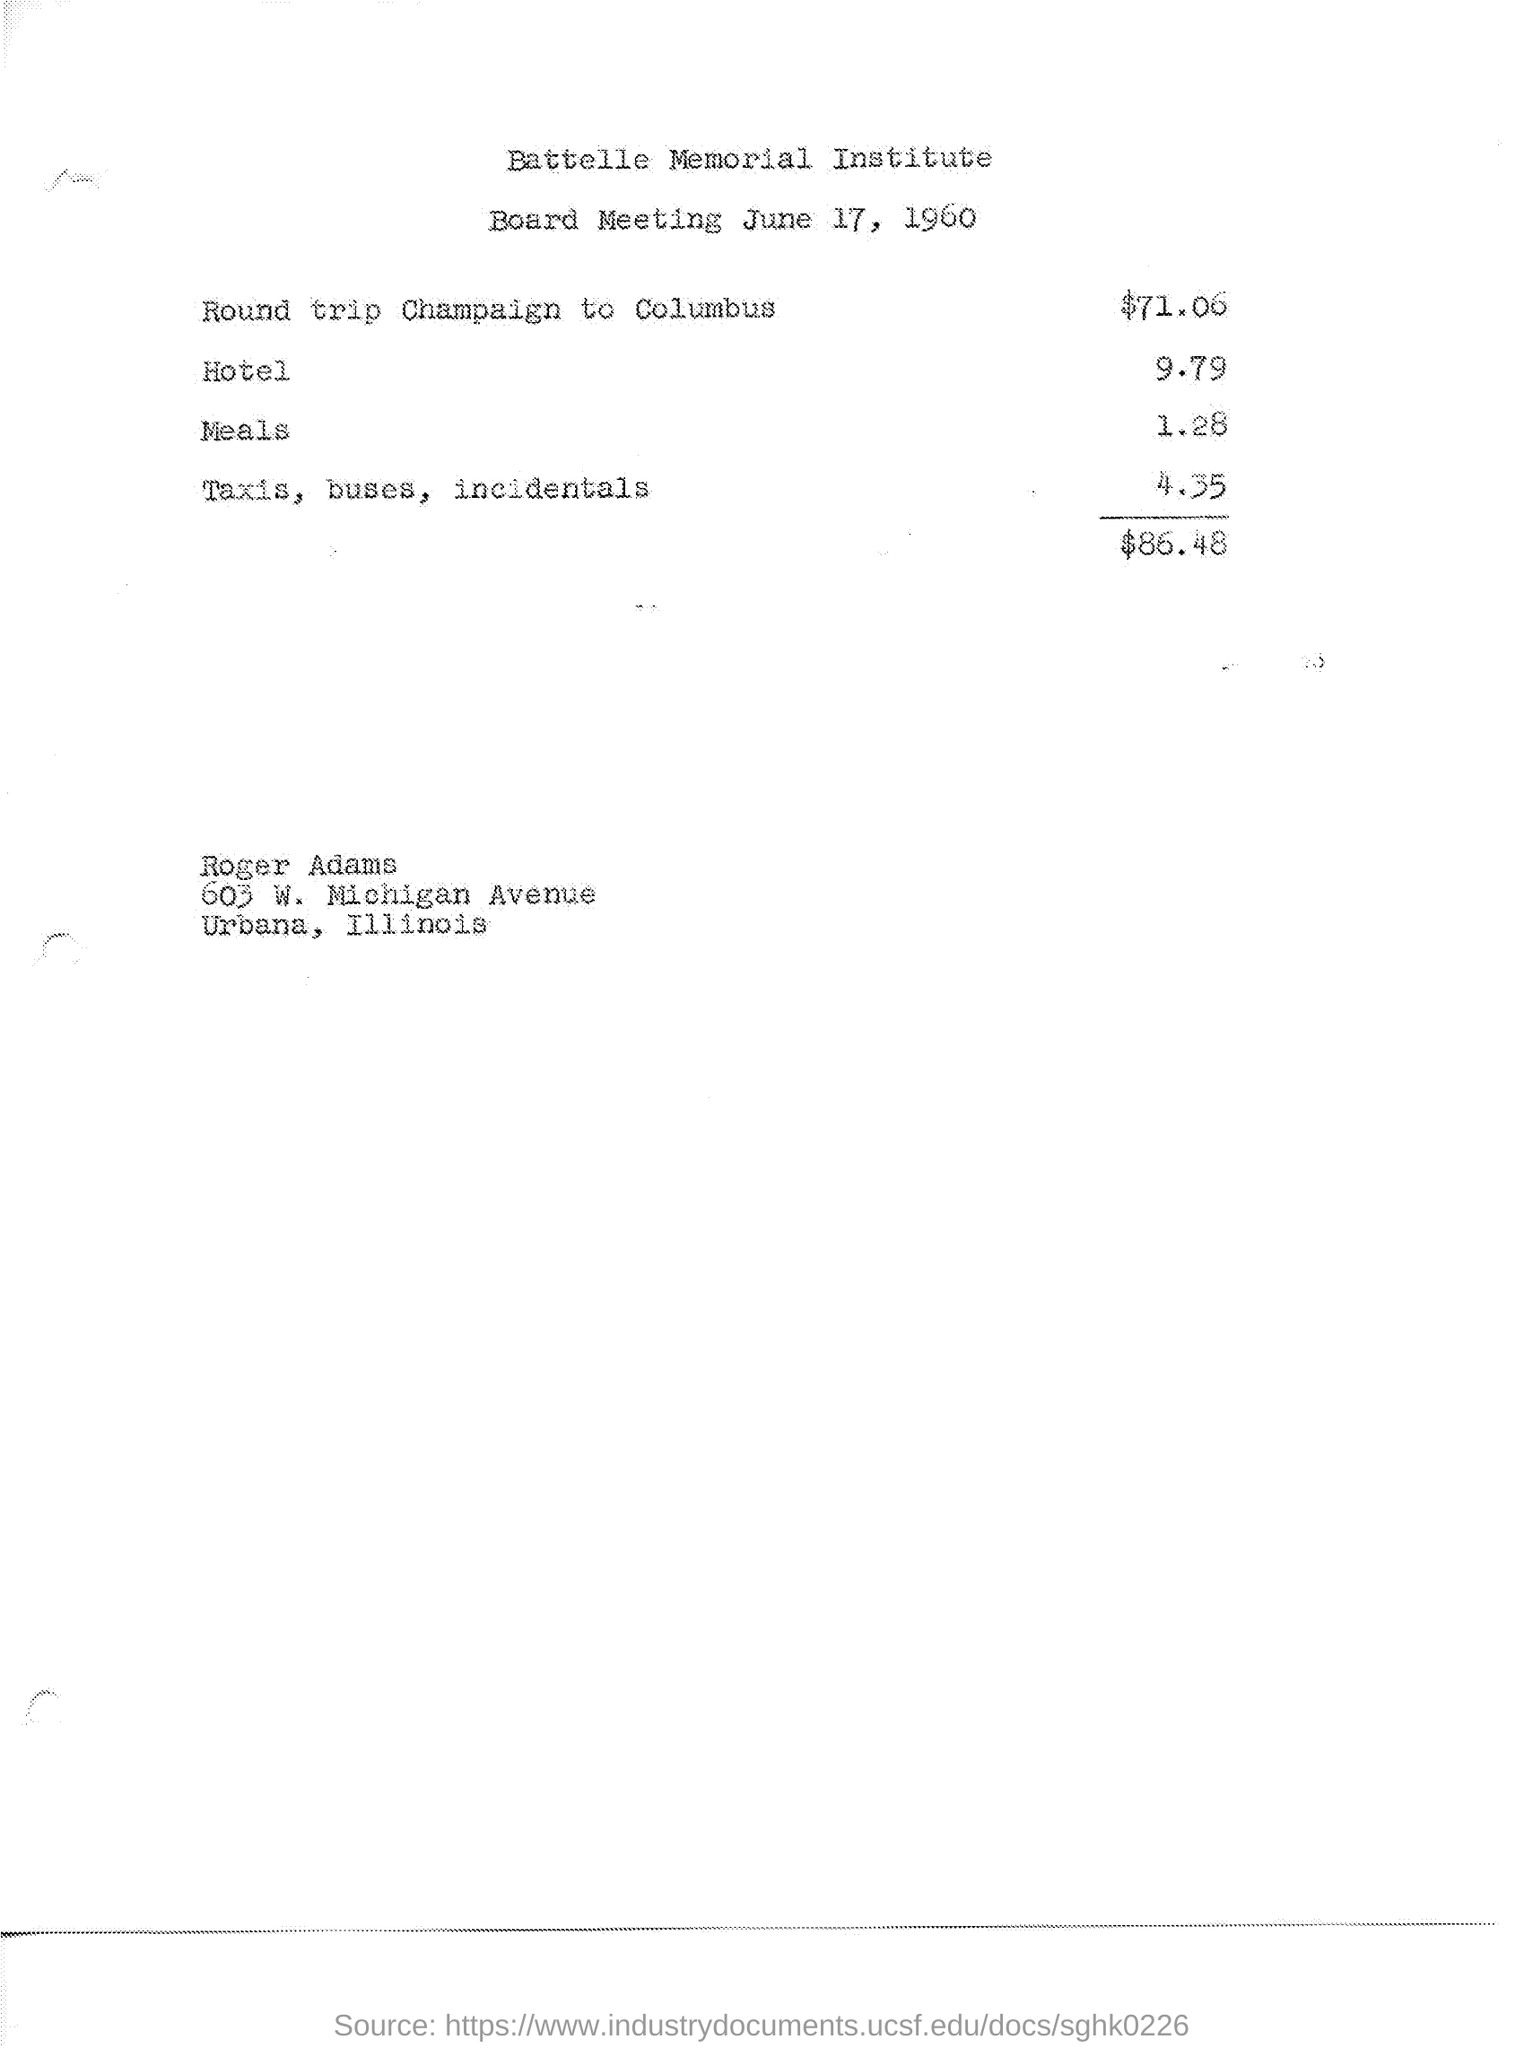List a handful of essential elements in this visual. The Battelle Memorial Institute is a name of an institute. The board meeting was held on June 17, 1960. 